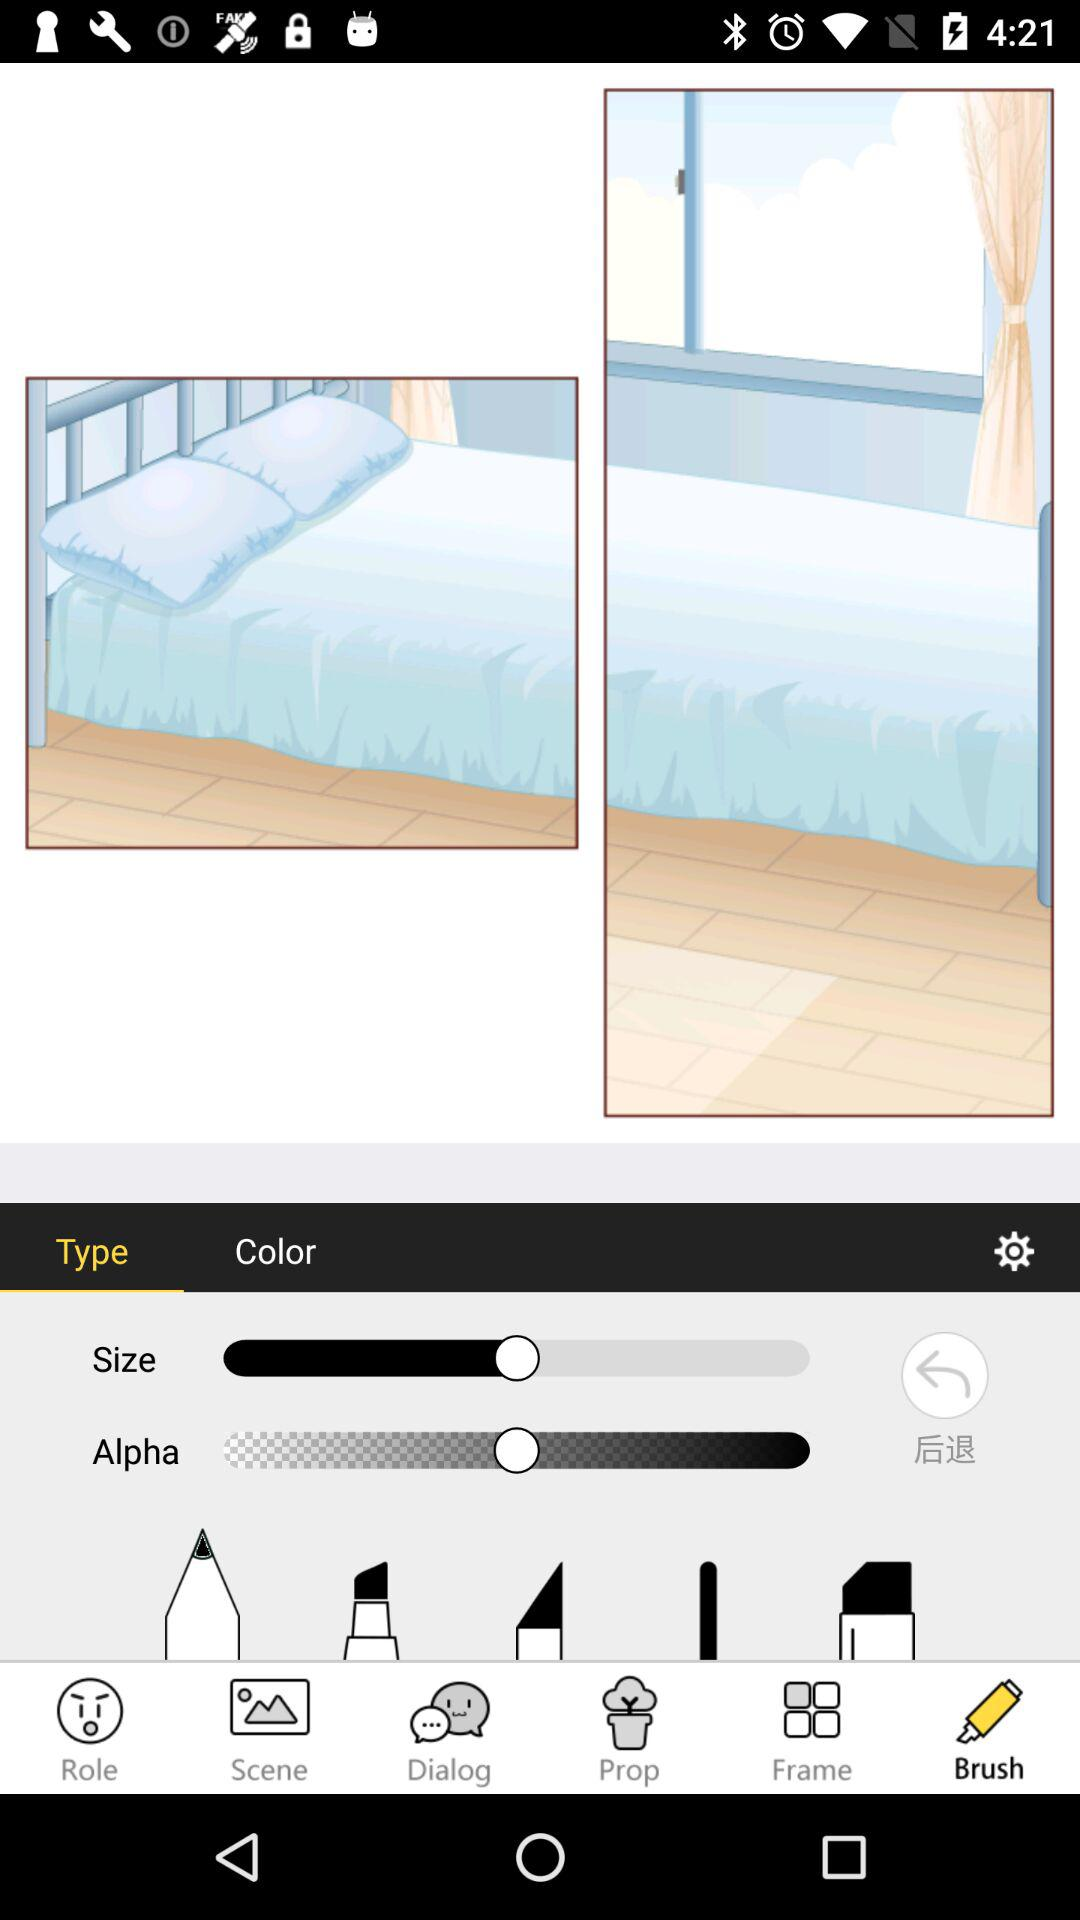Which option is selected on the bottom navigation bar? The selected option is "Brush". 